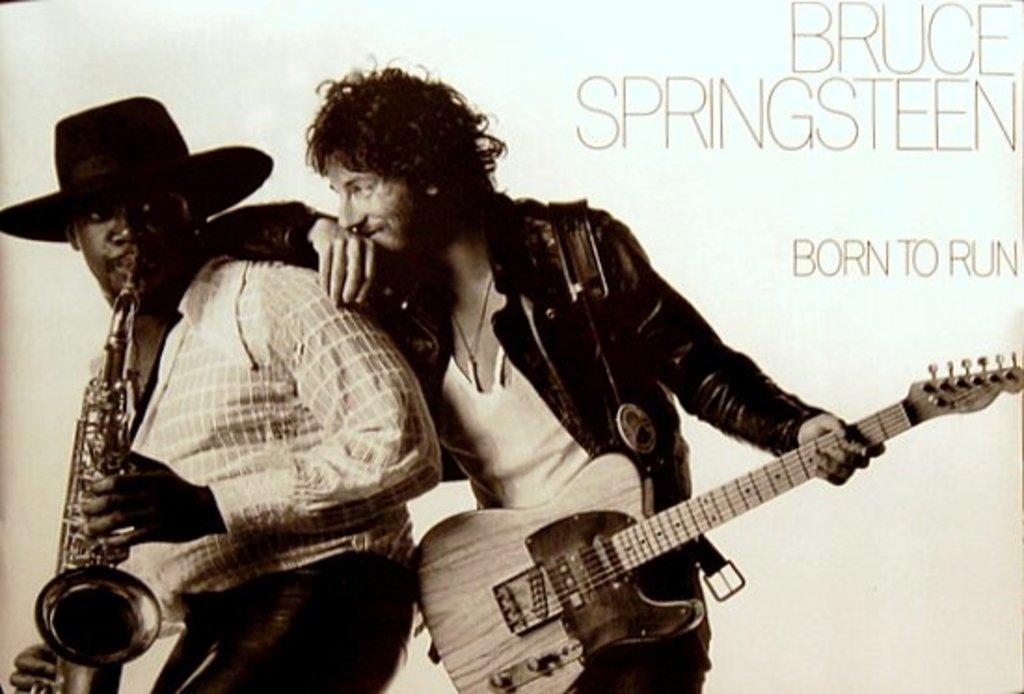Could you give a brief overview of what you see in this image? This looks like a poster which is in black and white format. There are two people standing. One man is holding a musical instrument and the other man is holding the guitar. I can see some letters written on the poster. Background is white in color. 